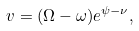<formula> <loc_0><loc_0><loc_500><loc_500>v = ( \Omega - \omega ) e ^ { \psi - \nu } ,</formula> 